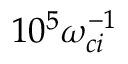<formula> <loc_0><loc_0><loc_500><loc_500>1 0 ^ { 5 } \omega _ { c i } ^ { - 1 }</formula> 